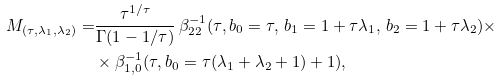<formula> <loc_0><loc_0><loc_500><loc_500>M _ { ( \tau , \lambda _ { 1 } , \lambda _ { 2 } ) } = & \frac { \tau ^ { 1 / \tau } } { \Gamma ( 1 - 1 / \tau ) } \, \beta ^ { - 1 } _ { 2 2 } ( \tau , b _ { 0 } = \tau , \, b _ { 1 } = 1 + \tau \lambda _ { 1 } , \, b _ { 2 } = 1 + \tau \lambda _ { 2 } ) \times \\ & \times \beta _ { 1 , 0 } ^ { - 1 } ( \tau , b _ { 0 } = \tau ( \lambda _ { 1 } + \lambda _ { 2 } + 1 ) + 1 ) ,</formula> 